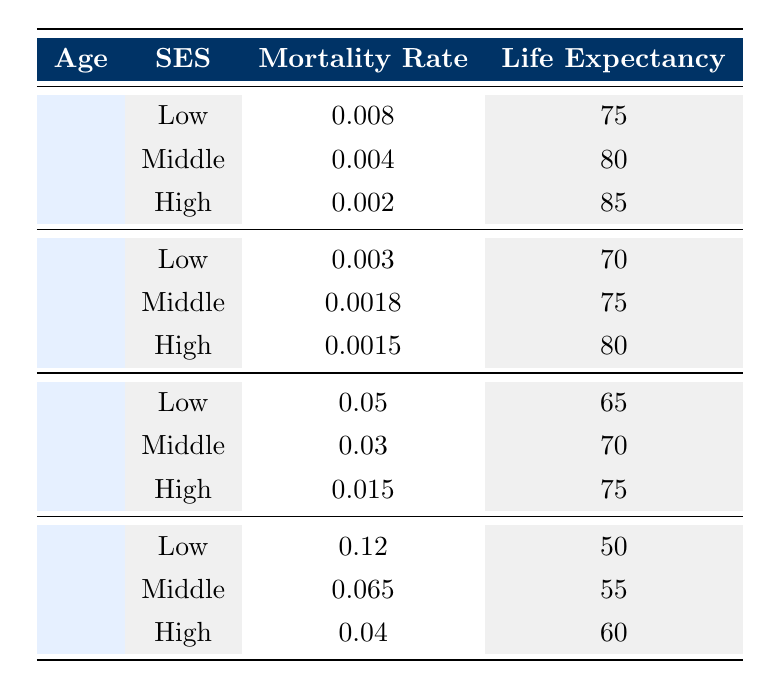What is the mortality rate for low socioeconomic status individuals aged 80? According to the table, for individuals aged 80 with low socioeconomic status, the mortality rate is listed as 0.12.
Answer: 0.12 What is the life expectancy for middle socioeconomic status individuals aged 65? The table shows that for individuals aged 65 with middle socioeconomic status, the life expectancy is 70 years.
Answer: 70 Which age group has the highest mortality rate for low socioeconomic status? Looking at the table, for low socioeconomic status, the age group 80 has the highest mortality rate of 0.12 compared to the other age groups: 0 (0.008), 40 (0.003), and 65 (0.05).
Answer: 80 Is the mortality rate for high socioeconomic status individuals lower than that for middle socioeconomic status at age 40? For age 40, the mortality rate for high socioeconomic status is 0.0015, while for middle socioeconomic status it is 0.0018. Since 0.0015 is lower than 0.0018, the statement is true.
Answer: Yes What is the average life expectancy of individuals aged 0 across all socioeconomic statuses? To find the average life expectancy for age 0, sum the life expectancies: (75 + 80 + 85) = 240. There are three entries, so the average is 240 / 3 = 80.
Answer: 80 What is the difference in mortality rate between low and high socioeconomic status for individuals aged 65? The mortality rate for low socioeconomic status at age 65 is 0.05, and for high socioeconomic status, it is 0.015. The difference is 0.05 - 0.015 = 0.035.
Answer: 0.035 For which socioeconomic status does life expectancy decrease the most between ages 0 and 80? For low socioeconomic status, life expectancy decreases from 75 to 50 (a decrease of 25 years), for middle it decreases from 80 to 55 (25 years), and for high from 85 to 60 (25 years). All show a decrease of 25 years.
Answer: All statuses decrease by 25 years Which age group experiences the highest life expectancy among the high socioeconomic status individuals? The age group 0 for high socioeconomic status has a life expectancy of 85, which is higher than the life expectancies at other ages: 80 (age 40, 75), 75 (age 65, 75), and 60 (age 80, 60).
Answer: 0 What is the total life expectancy for all low socioeconomic status individuals across the different age groups? The life expectancies for low socioeconomic status across ages are: 75 (age 0) + 70 (age 40) + 65 (age 65) + 50 (age 80) = 260.
Answer: 260 